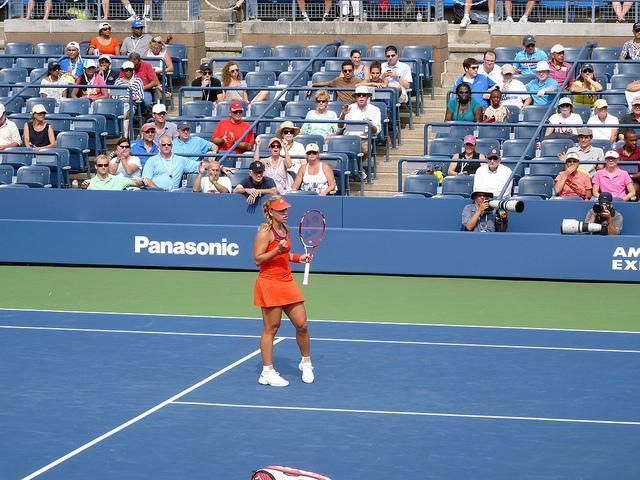How many people are in the photo?
Give a very brief answer. 2. How many beds in this image require a ladder to get into?
Give a very brief answer. 0. 